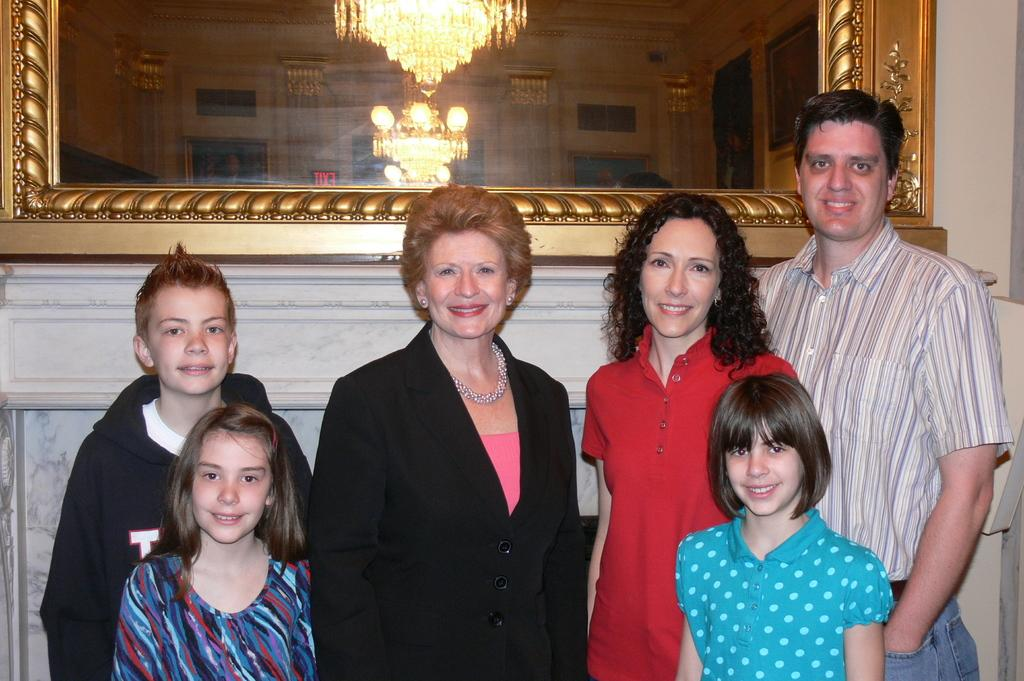What are the people in the image doing? The people in the image are standing in the center and smiling. What can be seen in the background of the image? There is a mirror on the wall and lights visible through the glass in the background. What type of stem can be seen growing out of the can in the image? There is no can or stem present in the image. What kind of vase is placed on the table in the image? There is no vase present in the image. 